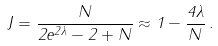<formula> <loc_0><loc_0><loc_500><loc_500>J = \frac { N } { 2 e ^ { 2 \lambda } - 2 + N } \approx 1 - \frac { 4 \lambda } { N } \, .</formula> 